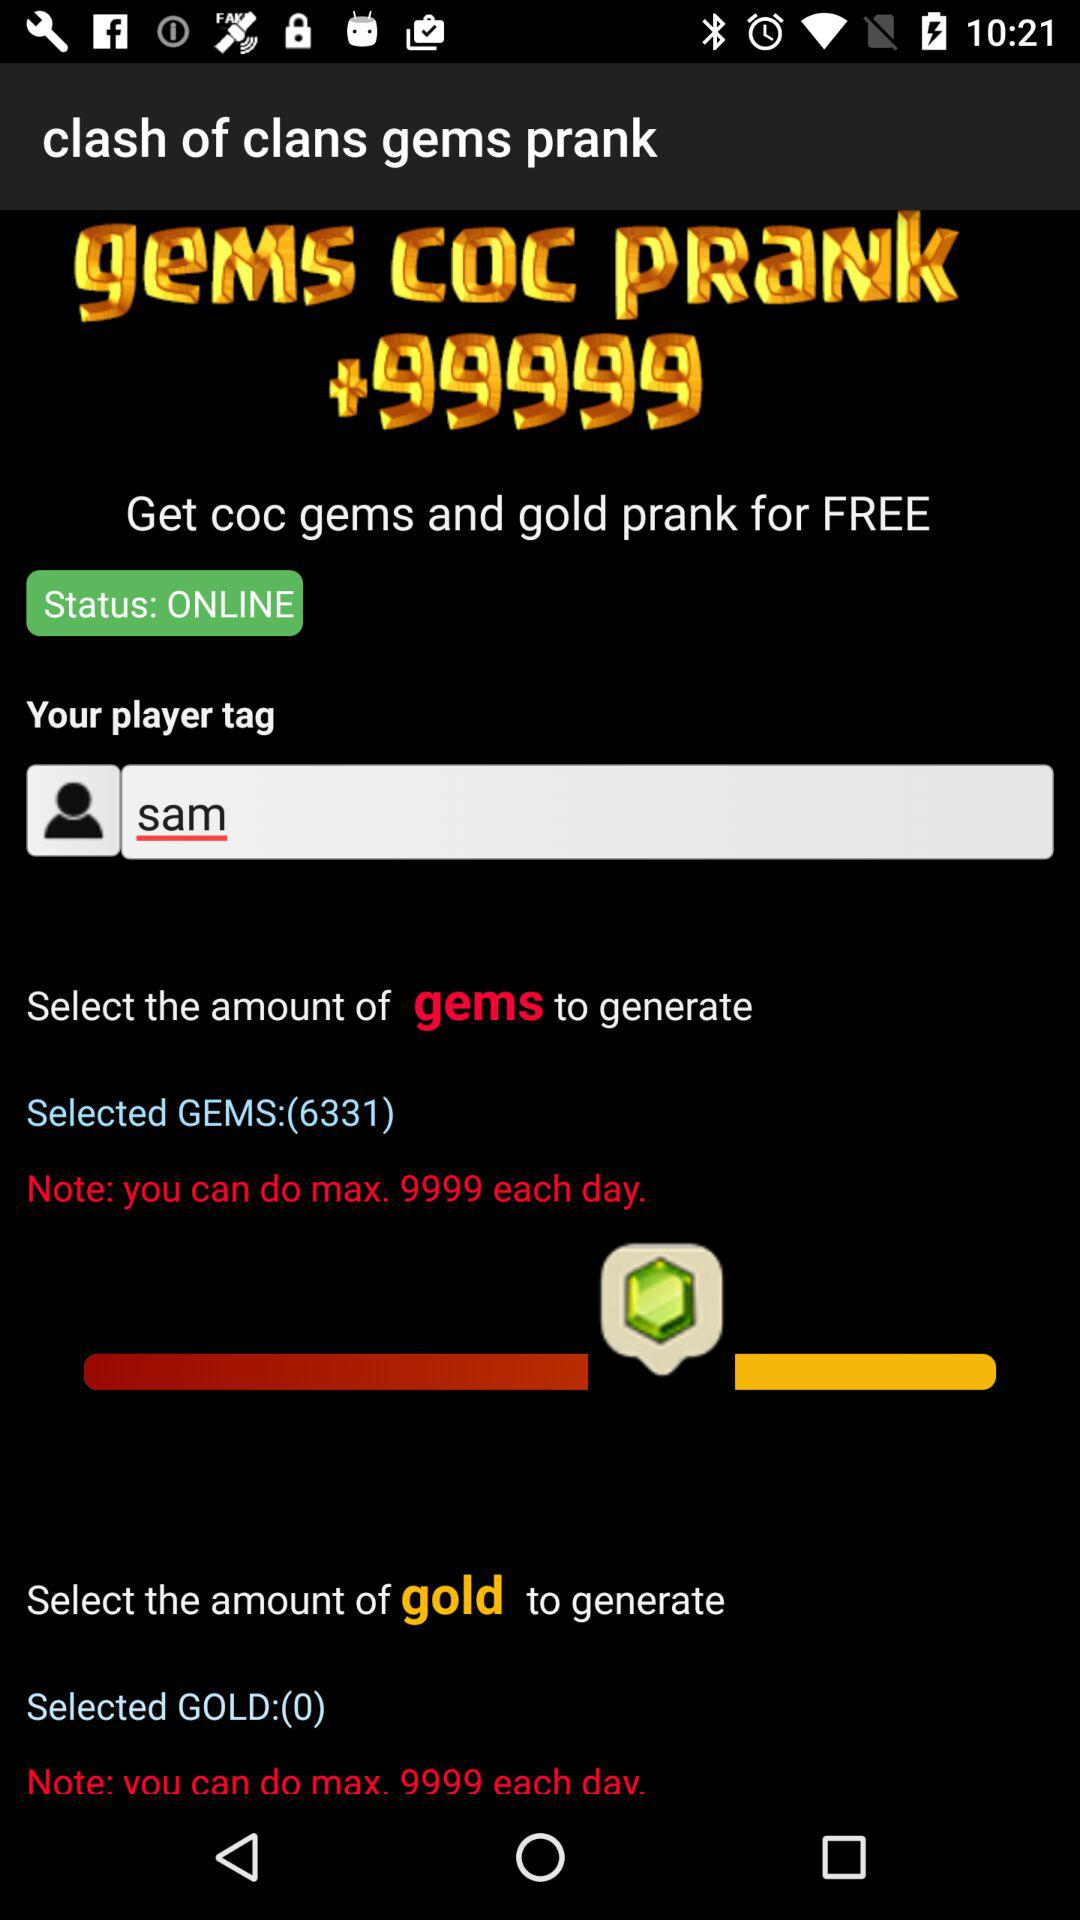What is to be selected to generate? To generate, the amount of gems and the amount of gold are to be selected. 